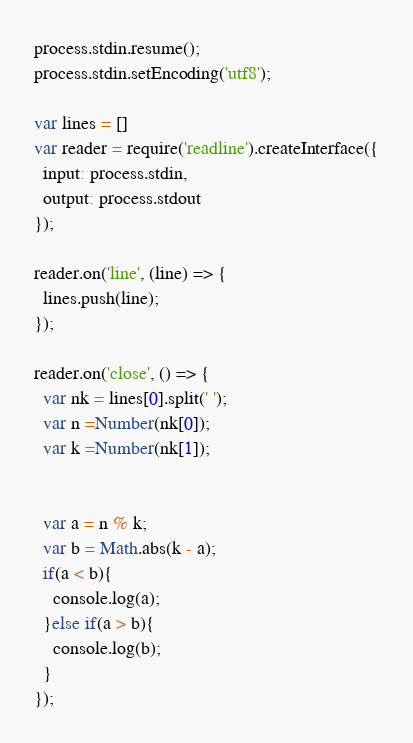<code> <loc_0><loc_0><loc_500><loc_500><_JavaScript_>process.stdin.resume();
process.stdin.setEncoding('utf8');

var lines = []
var reader = require('readline').createInterface({
  input: process.stdin,
  output: process.stdout
});

reader.on('line', (line) => {
  lines.push(line);
});

reader.on('close', () => {
  var nk = lines[0].split(' ');
  var n =Number(nk[0]);
  var k =Number(nk[1]);

  
  var a = n % k;
  var b = Math.abs(k - a);
  if(a < b){
    console.log(a);
  }else if(a > b){
    console.log(b);
  }
});</code> 